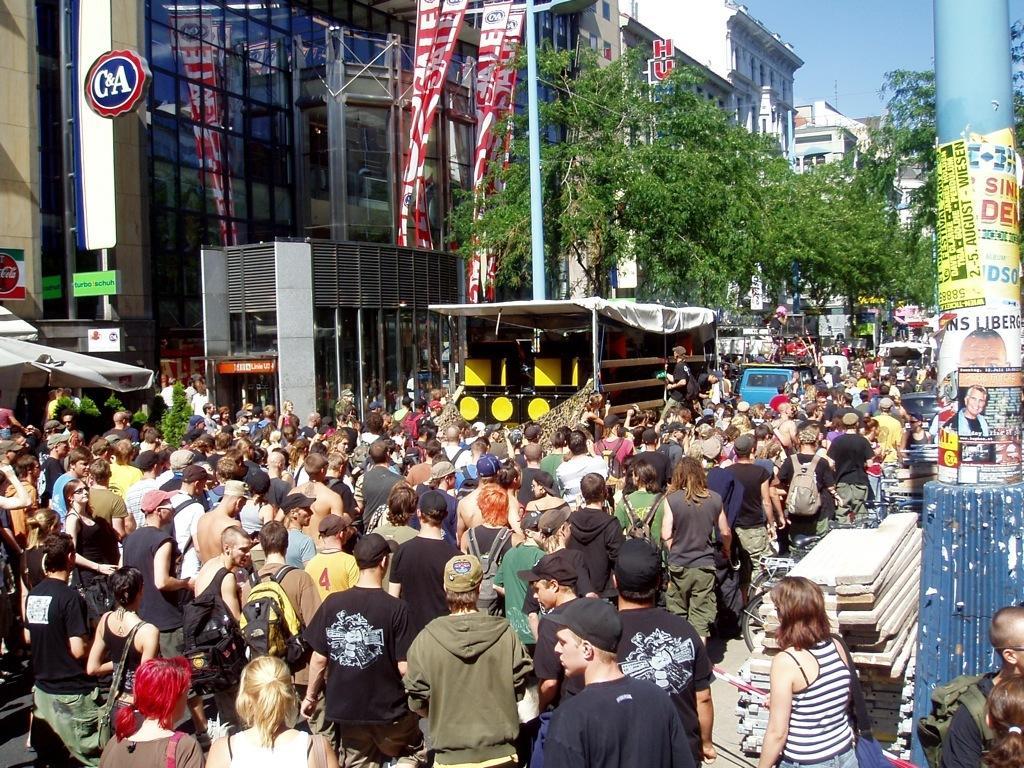How would you summarize this image in a sentence or two? In this image I can see number of persons are standing on the ground, few metal poles, few posters attached to the poles, few vehicles, few banners which are red and white in color, few buildings and few trees. In the background I can see the sky. 